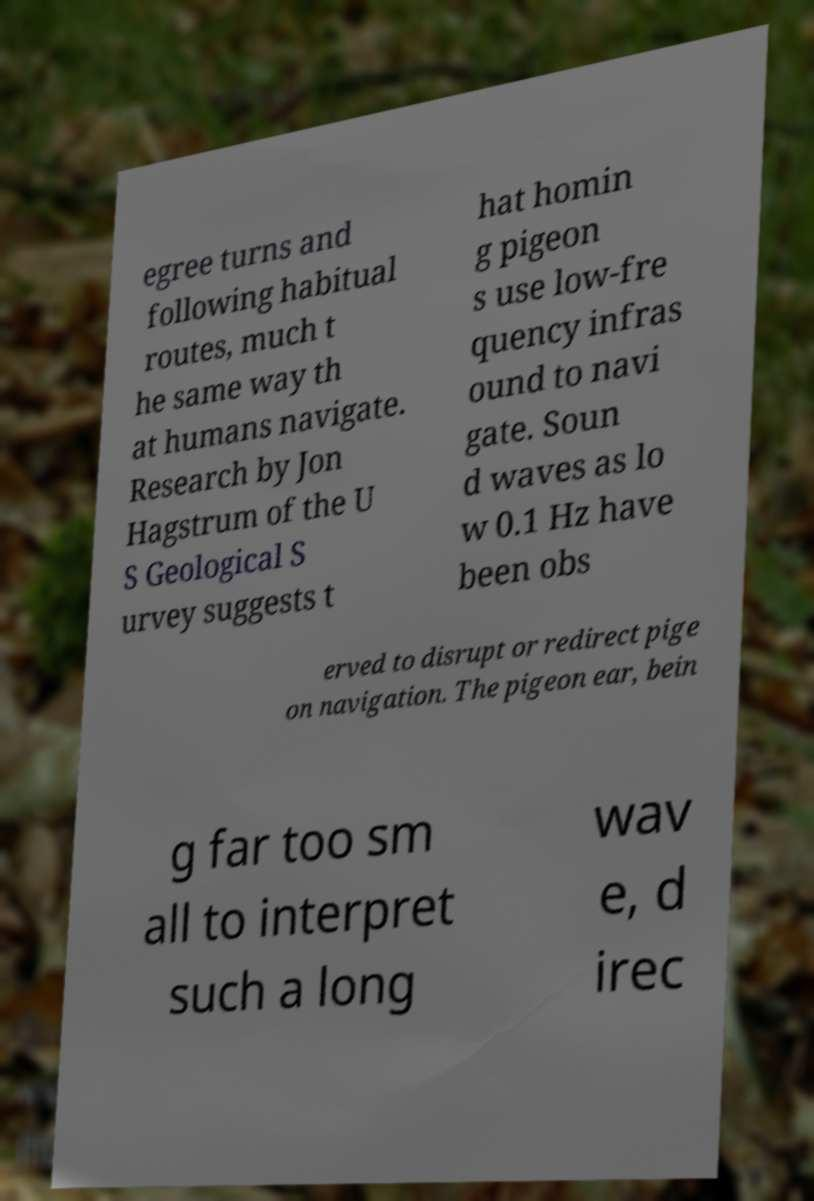Could you assist in decoding the text presented in this image and type it out clearly? egree turns and following habitual routes, much t he same way th at humans navigate. Research by Jon Hagstrum of the U S Geological S urvey suggests t hat homin g pigeon s use low-fre quency infras ound to navi gate. Soun d waves as lo w 0.1 Hz have been obs erved to disrupt or redirect pige on navigation. The pigeon ear, bein g far too sm all to interpret such a long wav e, d irec 